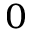Convert formula to latex. <formula><loc_0><loc_0><loc_500><loc_500>_ { 0 }</formula> 